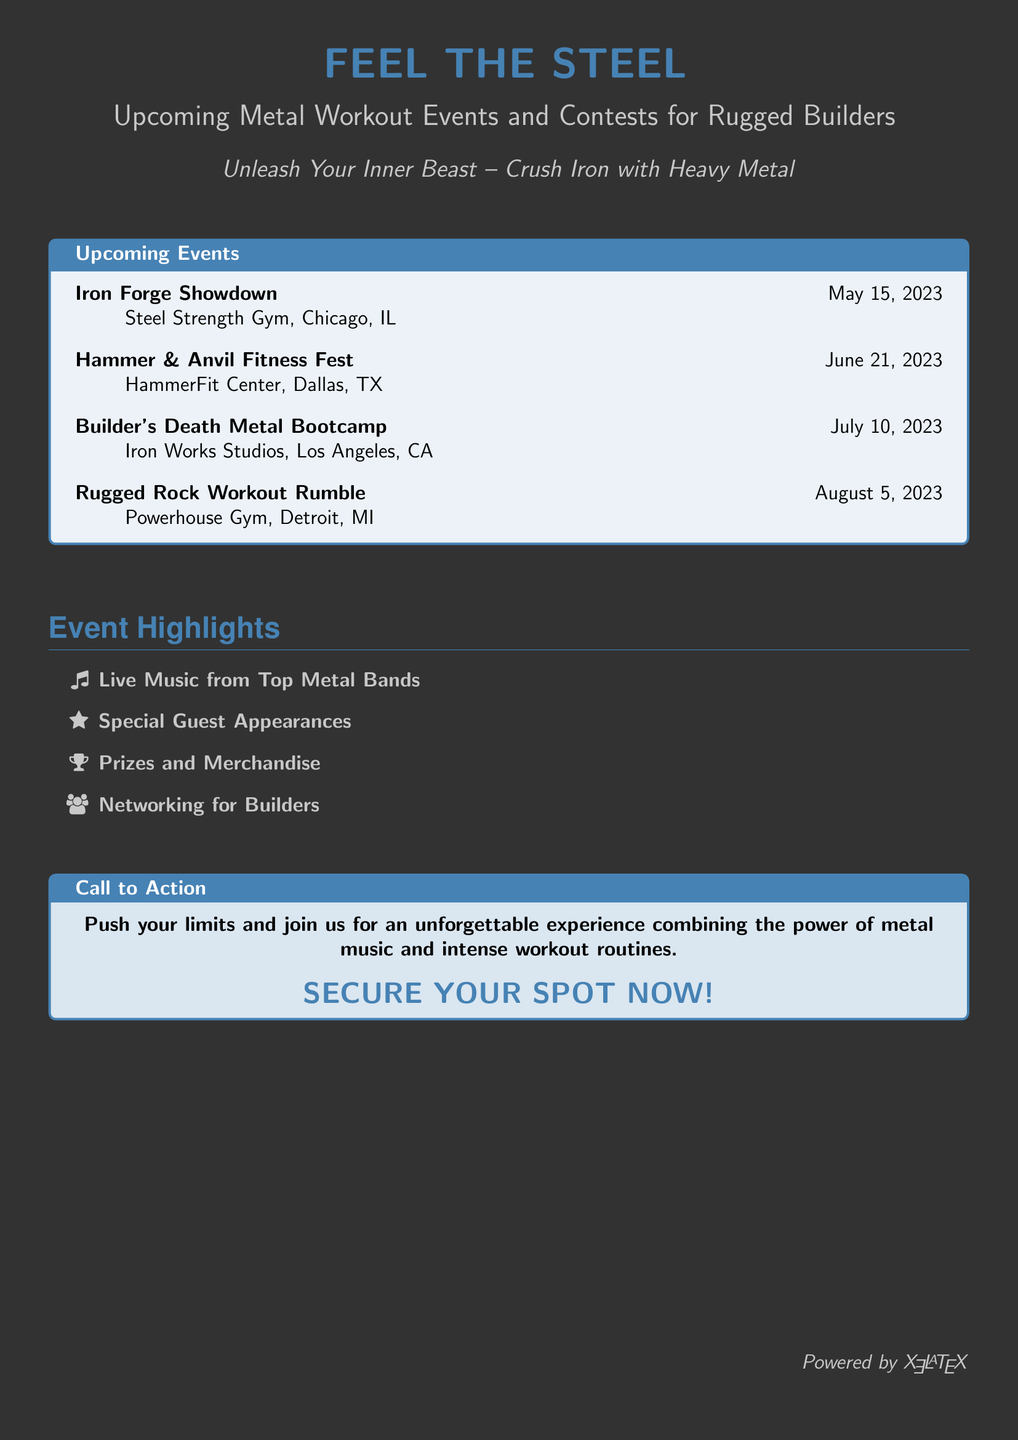what is the title of the first event? The title of the first event is listed under the upcoming events section, which states "Iron Forge Showdown."
Answer: Iron Forge Showdown when is the Builder's Death Metal Bootcamp? The date for this event is mentioned in the upcoming events, specifically on July 10, 2023.
Answer: July 10, 2023 where is the Hammer & Anvil Fitness Fest taking place? The location for this event is noted in the upcoming events section, specifically "HammerFit Center, Dallas, TX."
Answer: HammerFit Center, Dallas, TX how many events are listed in total? The document shows a list of four events under the upcoming events section, which includes Iron Forge Showdown, Hammer & Anvil Fitness Fest, Builder's Death Metal Bootcamp, and Rugged Rock Workout Rumble.
Answer: 4 what type of performances can participants expect at the events? The document highlights "Live Music from Top Metal Bands" as one of the features attendees can look forward to.
Answer: Live Music from Top Metal Bands what prizes are mentioned for the events? The advertisement specifies "Prizes and Merchandise" as one of the highlights for the events.
Answer: Prizes and Merchandise which city hosts the Rugged Rock Workout Rumble? The document specifies that this event takes place in "Detroit, MI."
Answer: Detroit, MI what should attendees do to participate? The advertisement suggests "SECURE YOUR SPOT NOW!" as a call to action for potential participants.
Answer: SECURE YOUR SPOT NOW 